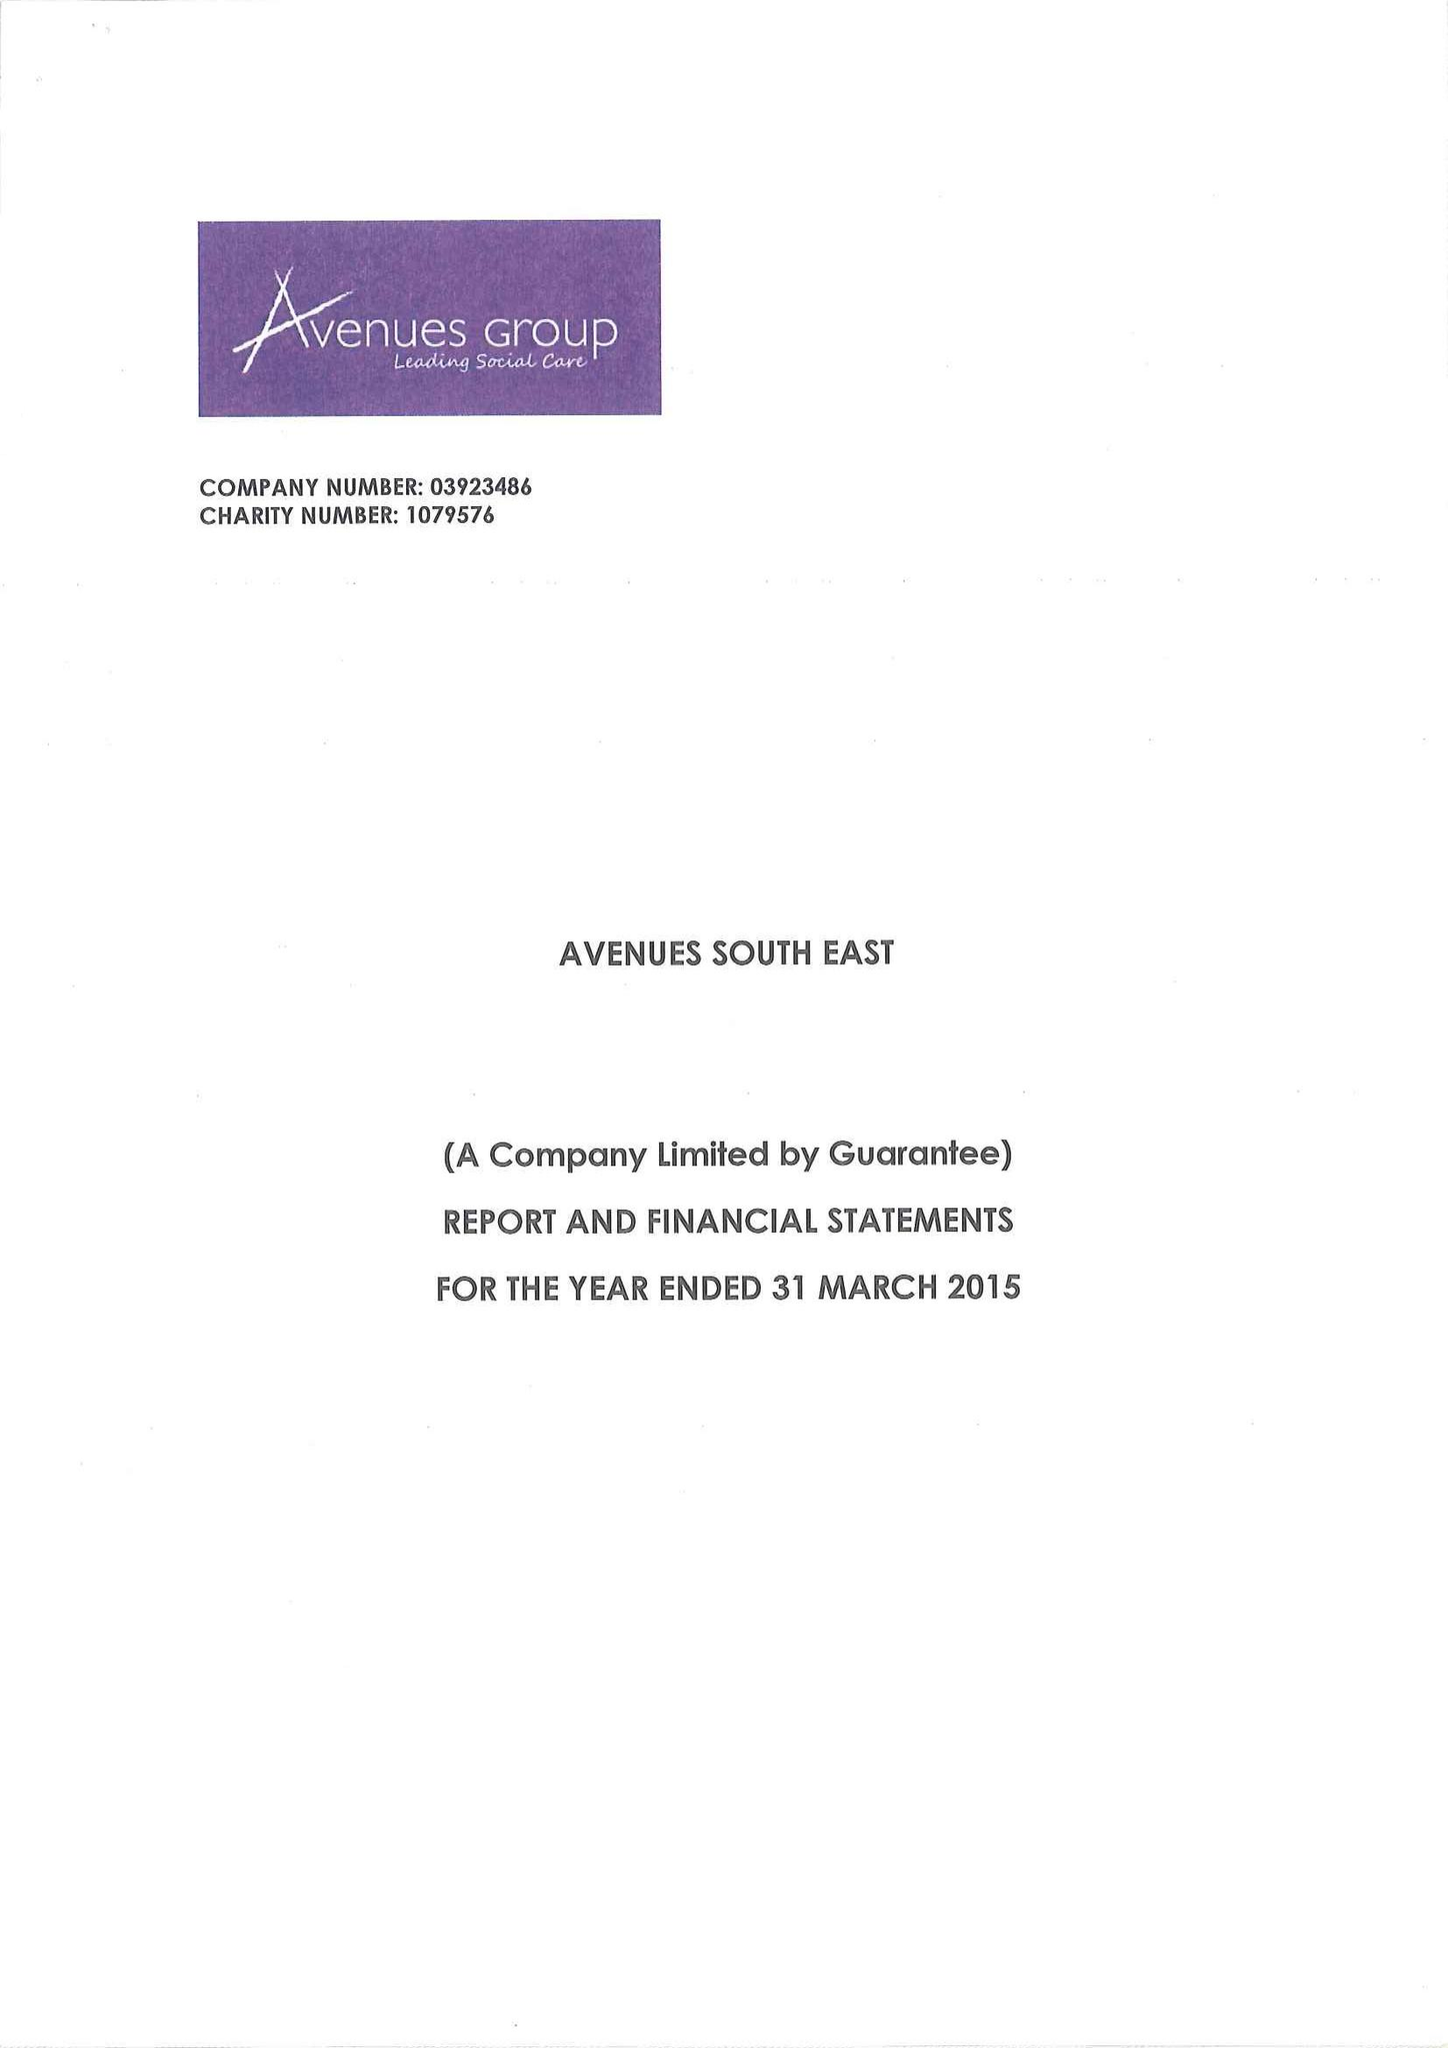What is the value for the charity_name?
Answer the question using a single word or phrase. Avenues South East 